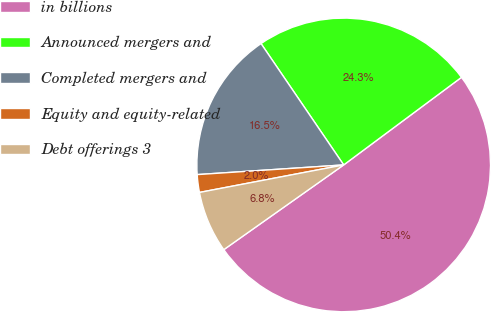<chart> <loc_0><loc_0><loc_500><loc_500><pie_chart><fcel>in billions<fcel>Announced mergers and<fcel>Completed mergers and<fcel>Equity and equity-related<fcel>Debt offerings 3<nl><fcel>50.38%<fcel>24.34%<fcel>16.53%<fcel>1.95%<fcel>6.79%<nl></chart> 